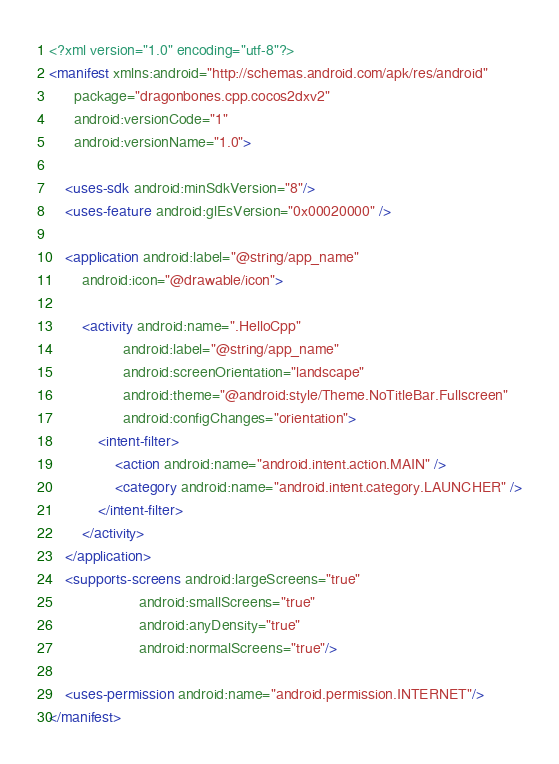<code> <loc_0><loc_0><loc_500><loc_500><_XML_><?xml version="1.0" encoding="utf-8"?>
<manifest xmlns:android="http://schemas.android.com/apk/res/android"
      package="dragonbones.cpp.cocos2dxv2"
      android:versionCode="1"
      android:versionName="1.0">

    <uses-sdk android:minSdkVersion="8"/>
    <uses-feature android:glEsVersion="0x00020000" />

    <application android:label="@string/app_name"
        android:icon="@drawable/icon">

        <activity android:name=".HelloCpp"
                  android:label="@string/app_name"
                  android:screenOrientation="landscape"
                  android:theme="@android:style/Theme.NoTitleBar.Fullscreen"
                  android:configChanges="orientation">
            <intent-filter>
                <action android:name="android.intent.action.MAIN" />
                <category android:name="android.intent.category.LAUNCHER" />
            </intent-filter>
        </activity>
    </application>
    <supports-screens android:largeScreens="true"
                      android:smallScreens="true"
                      android:anyDensity="true"
                      android:normalScreens="true"/>
                         
    <uses-permission android:name="android.permission.INTERNET"/>
</manifest> 
</code> 